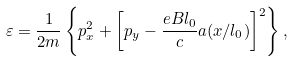Convert formula to latex. <formula><loc_0><loc_0><loc_500><loc_500>\varepsilon = \frac { 1 } { 2 m } \left \{ p _ { x } ^ { 2 } + \left [ p _ { y } - \frac { e B l _ { 0 } } { c } a ( x / l _ { 0 } ) \right ] ^ { 2 } \right \} ,</formula> 